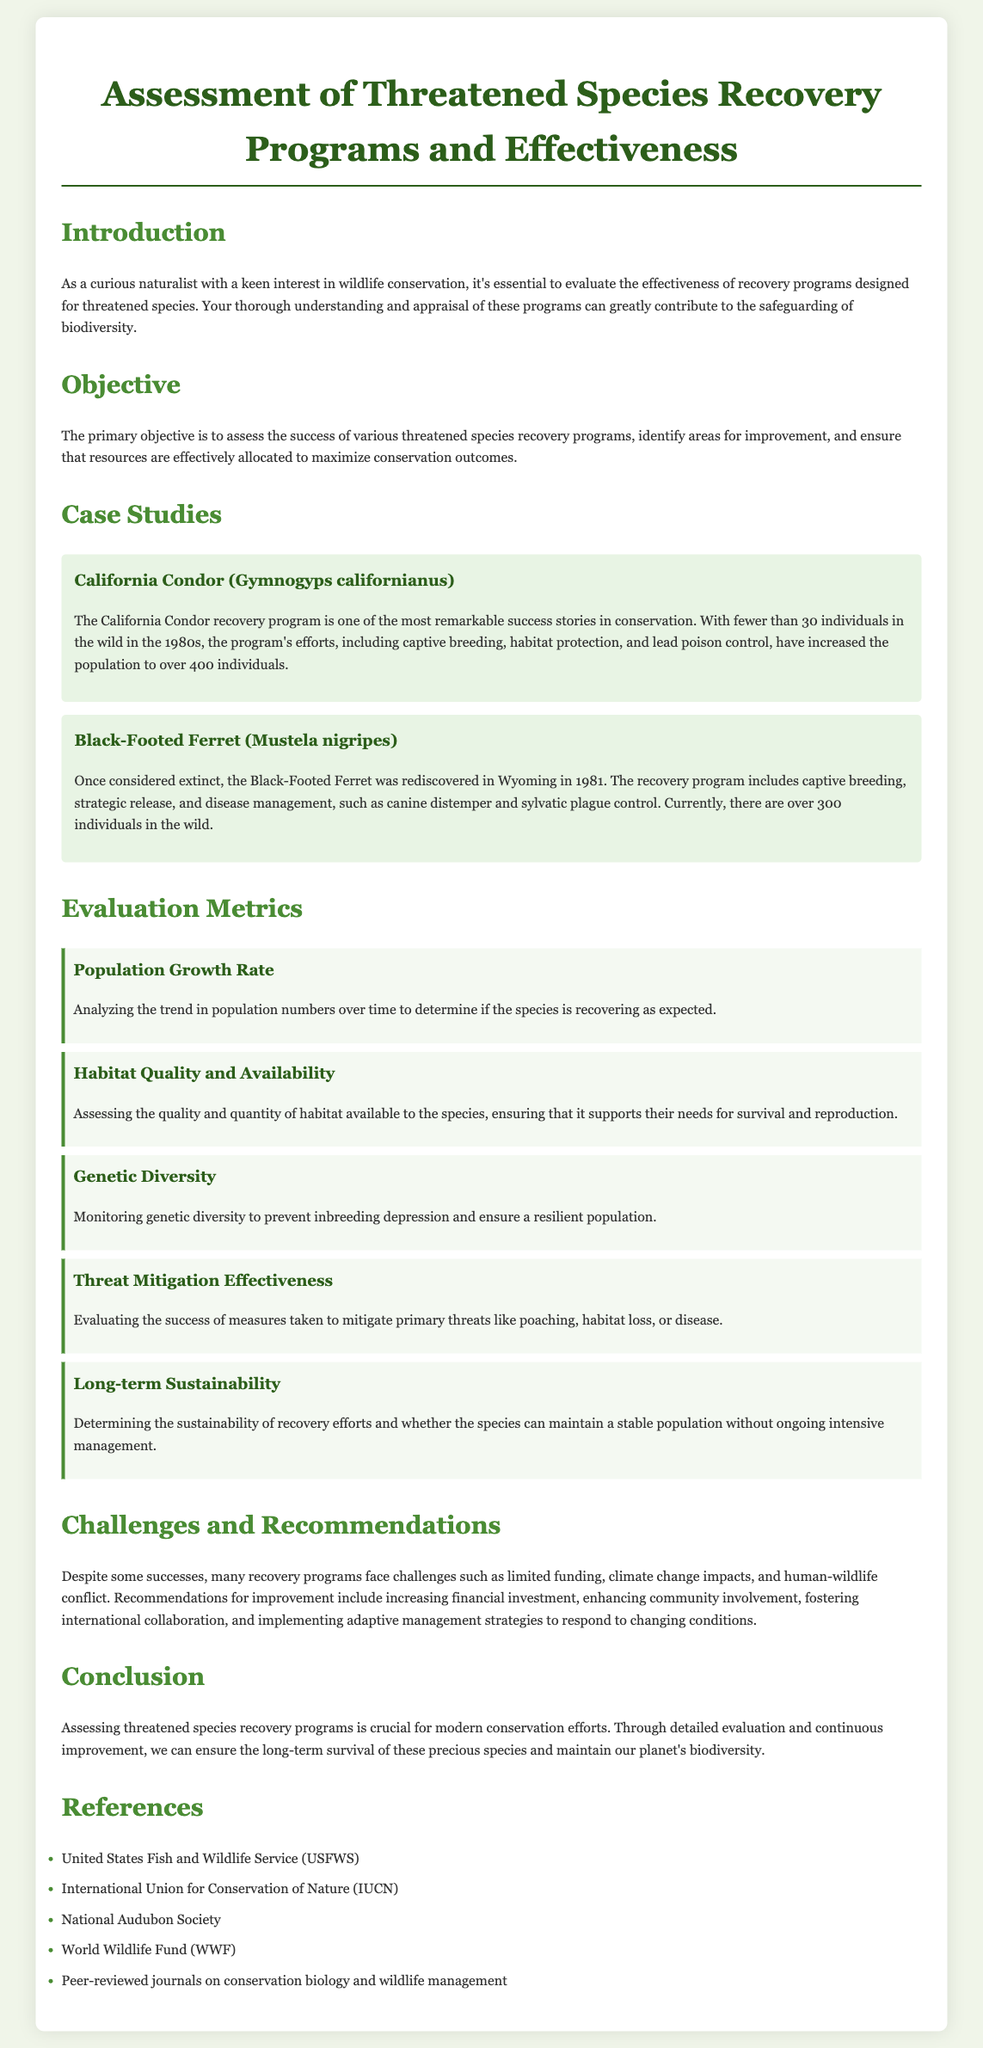What is the primary objective of the assessment? The primary objective is stated in the document to assess the success of recovery programs, identify areas for improvement, and ensure effective resource allocation.
Answer: assess the success of various threatened species recovery programs What species is mentioned as having fewer than 30 individuals in the wild in the 1980s? The California Condor is noted in the document for having fewer than 30 individuals in the wild during the 1980s.
Answer: California Condor How many California Condors are there currently? The document states that the population of California Condors has increased to over 400 individuals.
Answer: over 400 individuals What is one of the evaluation metrics listed? The document lists several evaluation metrics, including Population Growth Rate, among others.
Answer: Population Growth Rate What challenge is mentioned that recovery programs face? The text lists challenges such as limited funding, climate change impacts, and human-wildlife conflict.
Answer: limited funding What recommendation is provided for improving recovery programs? The document suggests increasing financial investment among other recommendations for improvement.
Answer: increasing financial investment Which organizations are listed in the references? The document contains references to organizations such as the United States Fish and Wildlife Service and the World Wildlife Fund.
Answer: United States Fish and Wildlife Service What species was once considered extinct? The Black-Footed Ferret is highlighted in the document as having been considered extinct before its rediscovery.
Answer: Black-Footed Ferret How many Black-Footed Ferrets are there currently? The document states that there are currently over 300 individuals in the wild.
Answer: over 300 individuals What is one method used in the Black-Footed Ferret recovery program? The document mentions methods such as captive breeding and disease management as part of the recovery efforts.
Answer: captive breeding 